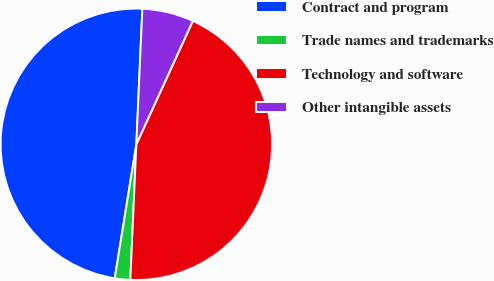Convert chart to OTSL. <chart><loc_0><loc_0><loc_500><loc_500><pie_chart><fcel>Contract and program<fcel>Trade names and trademarks<fcel>Technology and software<fcel>Other intangible assets<nl><fcel>48.16%<fcel>1.84%<fcel>43.87%<fcel>6.13%<nl></chart> 